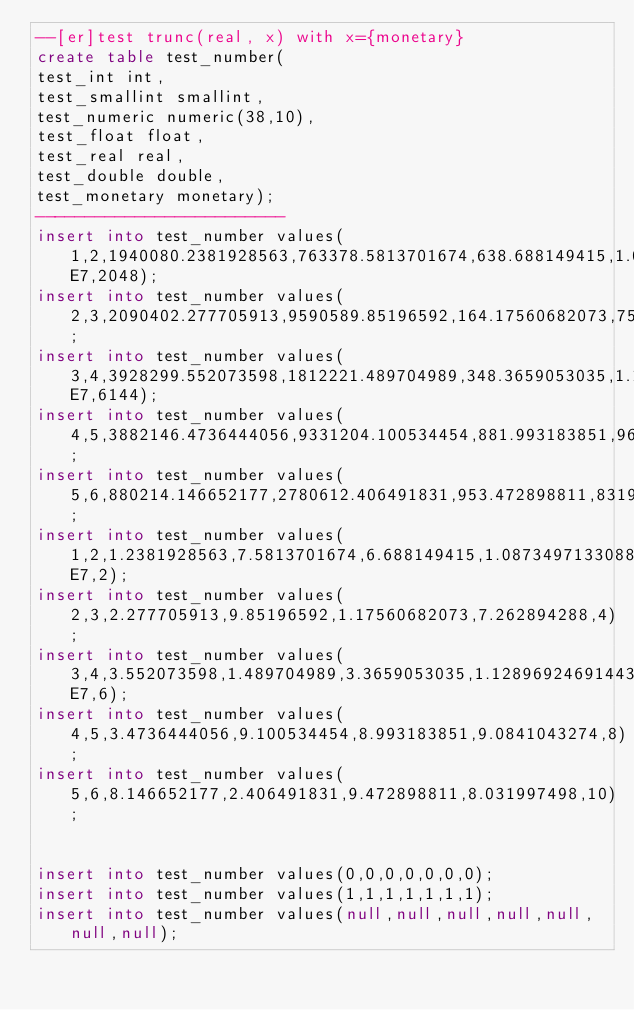Convert code to text. <code><loc_0><loc_0><loc_500><loc_500><_SQL_>--[er]test trunc(real, x) with x={monetary}
create table test_number(
test_int int,		
test_smallint smallint,		
test_numeric numeric(38,10),		
test_float float,		
test_real real,		
test_double double, 		
test_monetary monetary);
-------------------------
insert into test_number values( 1,2,1940080.2381928563,763378.5813701674,638.688149415,1.0873497133088402E7,2048);
insert into test_number values( 2,3,2090402.277705913,9590589.85196592,164.17560682073,7523328.262894288,4096);
insert into test_number values( 3,4,3928299.552073598,1812221.489704989,348.3659053035,1.1289692469144318E7,6144);
insert into test_number values( 4,5,3882146.4736444056,9331204.100534454,881.993183851,966880.0841043274,8192);
insert into test_number values( 5,6,880214.146652177,2780612.406491831,953.472898811,8319367.031997498,10240);
insert into test_number values( 1,2,1.2381928563,7.5813701674,6.688149415,1.0873497133088402E7,2);
insert into test_number values( 2,3,2.277705913,9.85196592,1.17560682073,7.262894288,4);
insert into test_number values( 3,4,3.552073598,1.489704989,3.3659053035,1.1289692469144318E7,6);
insert into test_number values( 4,5,3.4736444056,9.100534454,8.993183851,9.0841043274,8);
insert into test_number values( 5,6,8.146652177,2.406491831,9.472898811,8.031997498,10);


insert into test_number values(0,0,0,0,0,0,0);
insert into test_number values(1,1,1,1,1,1,1);
insert into test_number values(null,null,null,null,null,null,null);

</code> 